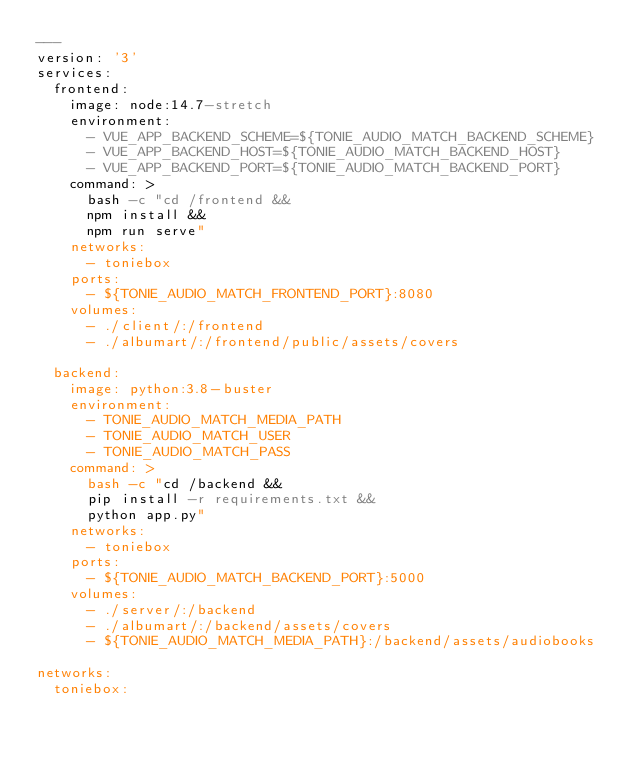<code> <loc_0><loc_0><loc_500><loc_500><_YAML_>---
version: '3'
services:
  frontend:
    image: node:14.7-stretch
    environment:
      - VUE_APP_BACKEND_SCHEME=${TONIE_AUDIO_MATCH_BACKEND_SCHEME}
      - VUE_APP_BACKEND_HOST=${TONIE_AUDIO_MATCH_BACKEND_HOST}
      - VUE_APP_BACKEND_PORT=${TONIE_AUDIO_MATCH_BACKEND_PORT}
    command: >
      bash -c "cd /frontend &&
      npm install &&
      npm run serve"
    networks:
      - toniebox
    ports:
      - ${TONIE_AUDIO_MATCH_FRONTEND_PORT}:8080
    volumes:
      - ./client/:/frontend
      - ./albumart/:/frontend/public/assets/covers

  backend:
    image: python:3.8-buster
    environment:
      - TONIE_AUDIO_MATCH_MEDIA_PATH
      - TONIE_AUDIO_MATCH_USER
      - TONIE_AUDIO_MATCH_PASS
    command: >
      bash -c "cd /backend &&
      pip install -r requirements.txt &&
      python app.py"
    networks:
      - toniebox
    ports:
      - ${TONIE_AUDIO_MATCH_BACKEND_PORT}:5000
    volumes:
      - ./server/:/backend
      - ./albumart/:/backend/assets/covers
      - ${TONIE_AUDIO_MATCH_MEDIA_PATH}:/backend/assets/audiobooks

networks:
  toniebox:</code> 